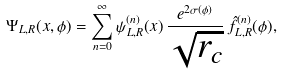<formula> <loc_0><loc_0><loc_500><loc_500>\Psi _ { L , R } ( x , \phi ) = \sum _ { n = 0 } ^ { \infty } \psi _ { L , R } ^ { ( n ) } ( x ) \, \frac { e ^ { 2 \sigma ( \phi ) } } { \sqrt { r _ { c } } } \, \hat { f } ^ { ( n ) } _ { L , R } ( \phi ) ,</formula> 